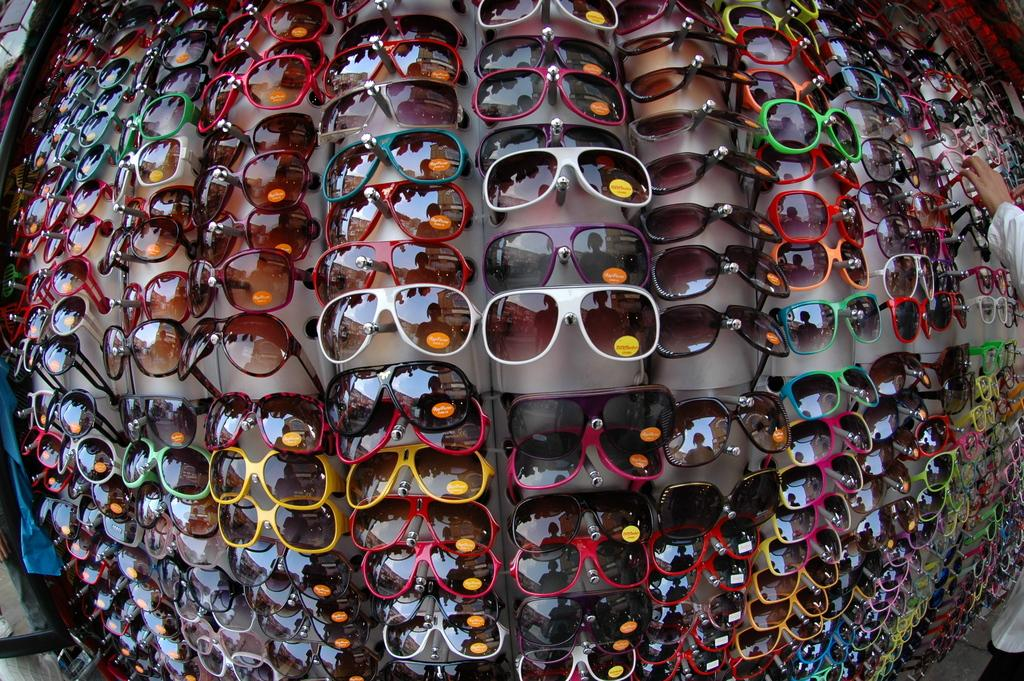What is the main subject of the image? The main subject of the image is a displaying stand with sunglasses. What is the human hand doing in the image? The human hand is picking one of the sunglasses. What type of design can be seen on the crow's feathers in the image? There is no crow present in the image, so it is not possible to determine the design on its feathers. 